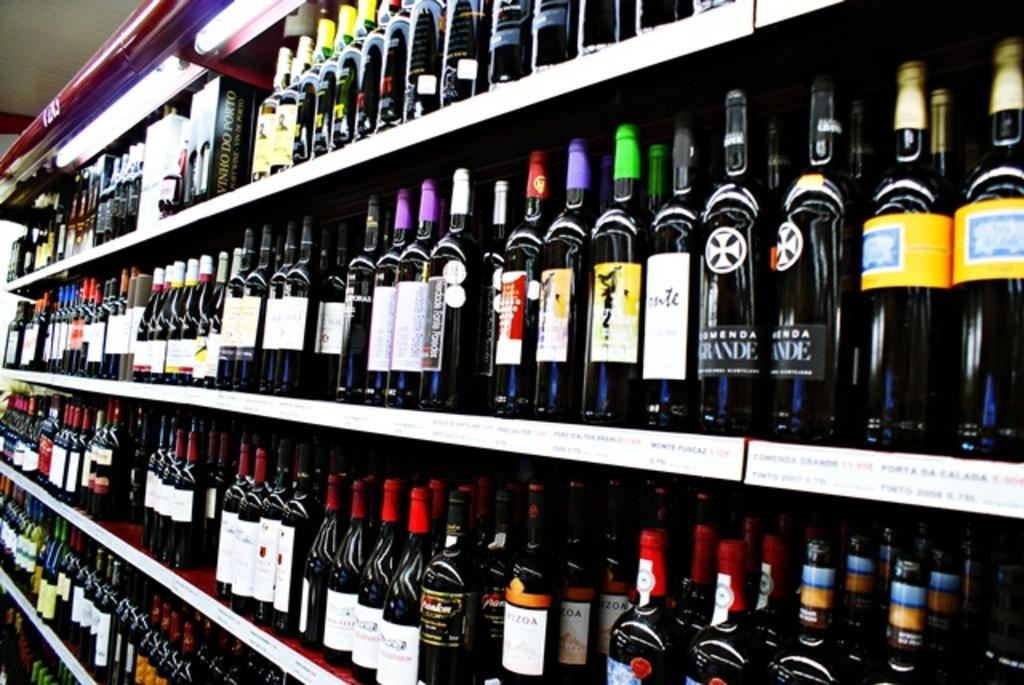<image>
Give a short and clear explanation of the subsequent image. The black bottle with the black label says Grande 